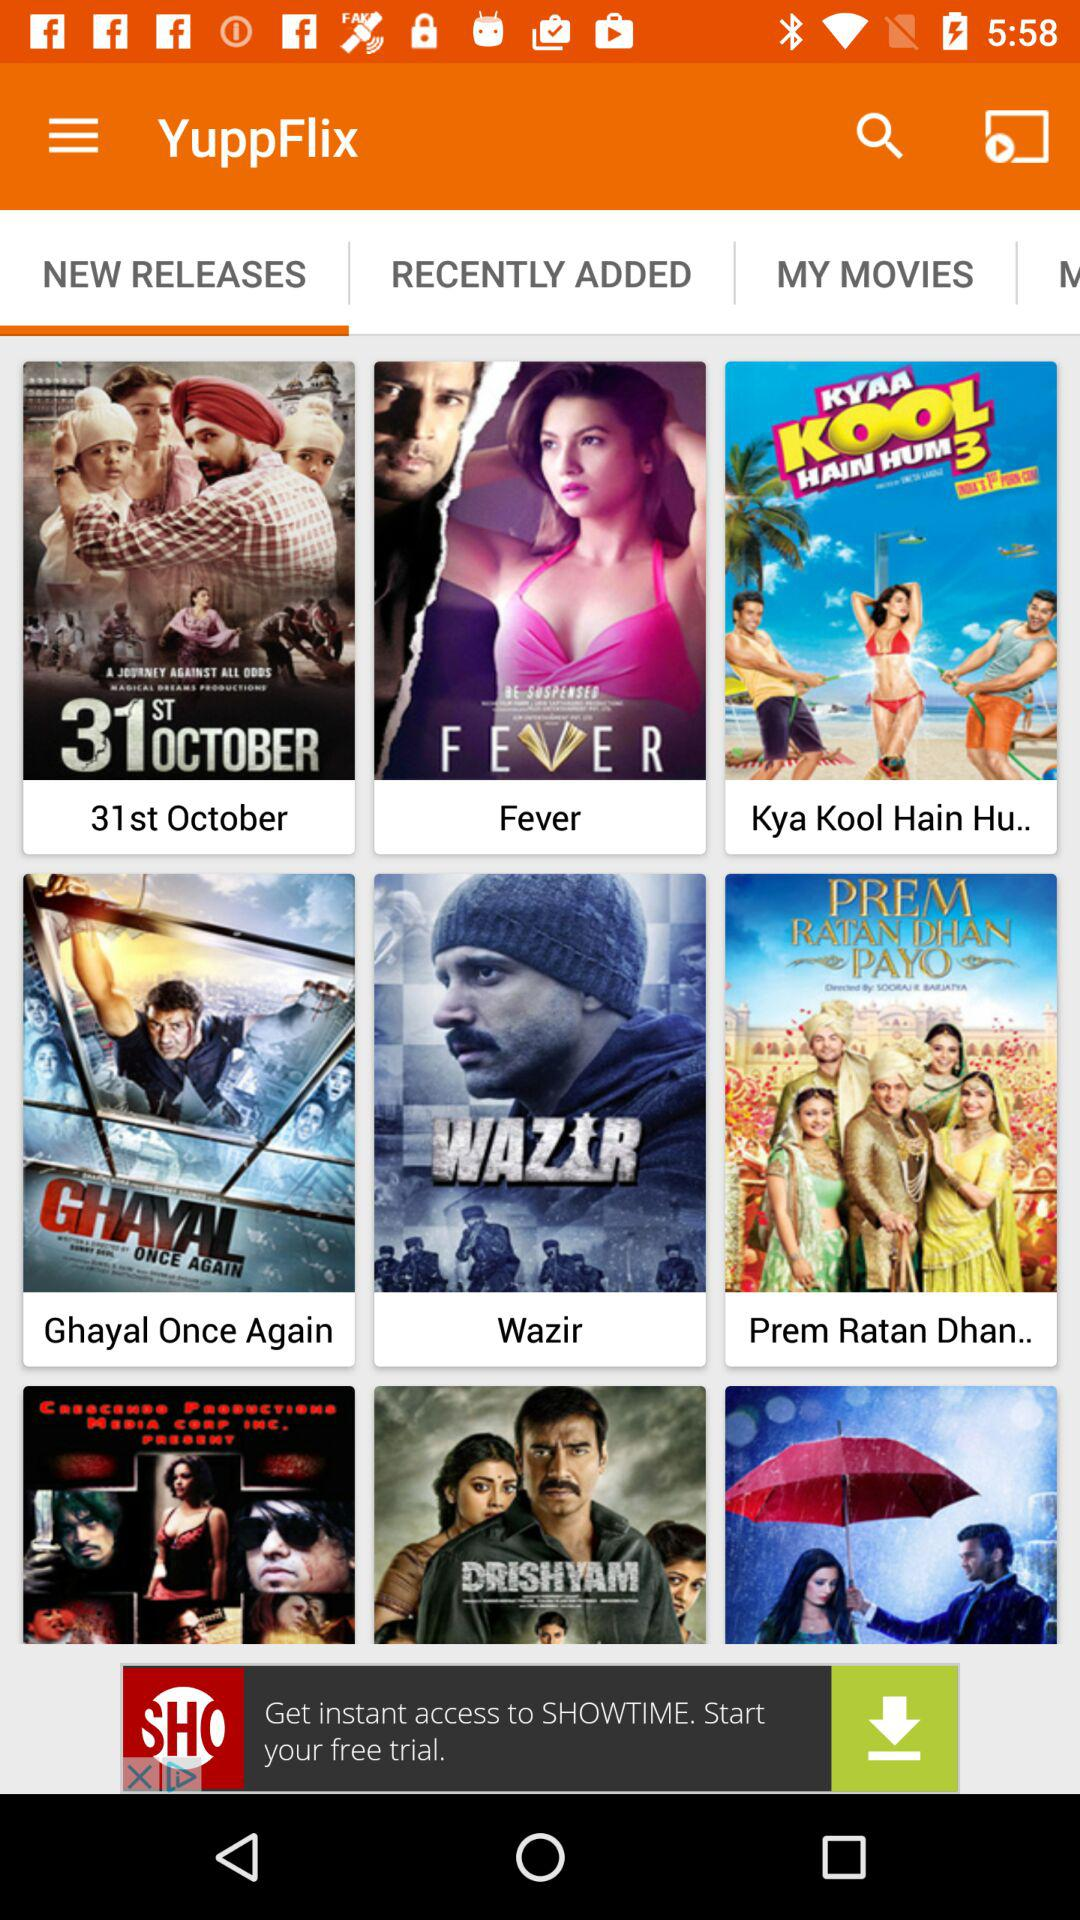What is the application name? The application name is "YuppFlix". 